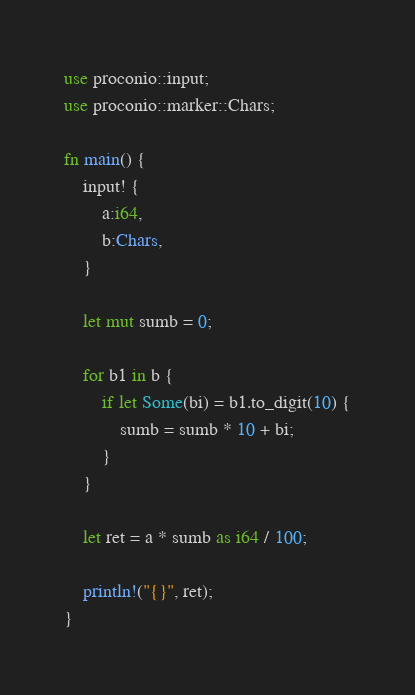<code> <loc_0><loc_0><loc_500><loc_500><_Rust_>use proconio::input;
use proconio::marker::Chars;

fn main() {
    input! {
        a:i64,
        b:Chars,
    }

    let mut sumb = 0;

    for b1 in b {
        if let Some(bi) = b1.to_digit(10) {
            sumb = sumb * 10 + bi;
        }
    }

    let ret = a * sumb as i64 / 100;

    println!("{}", ret);
}
</code> 